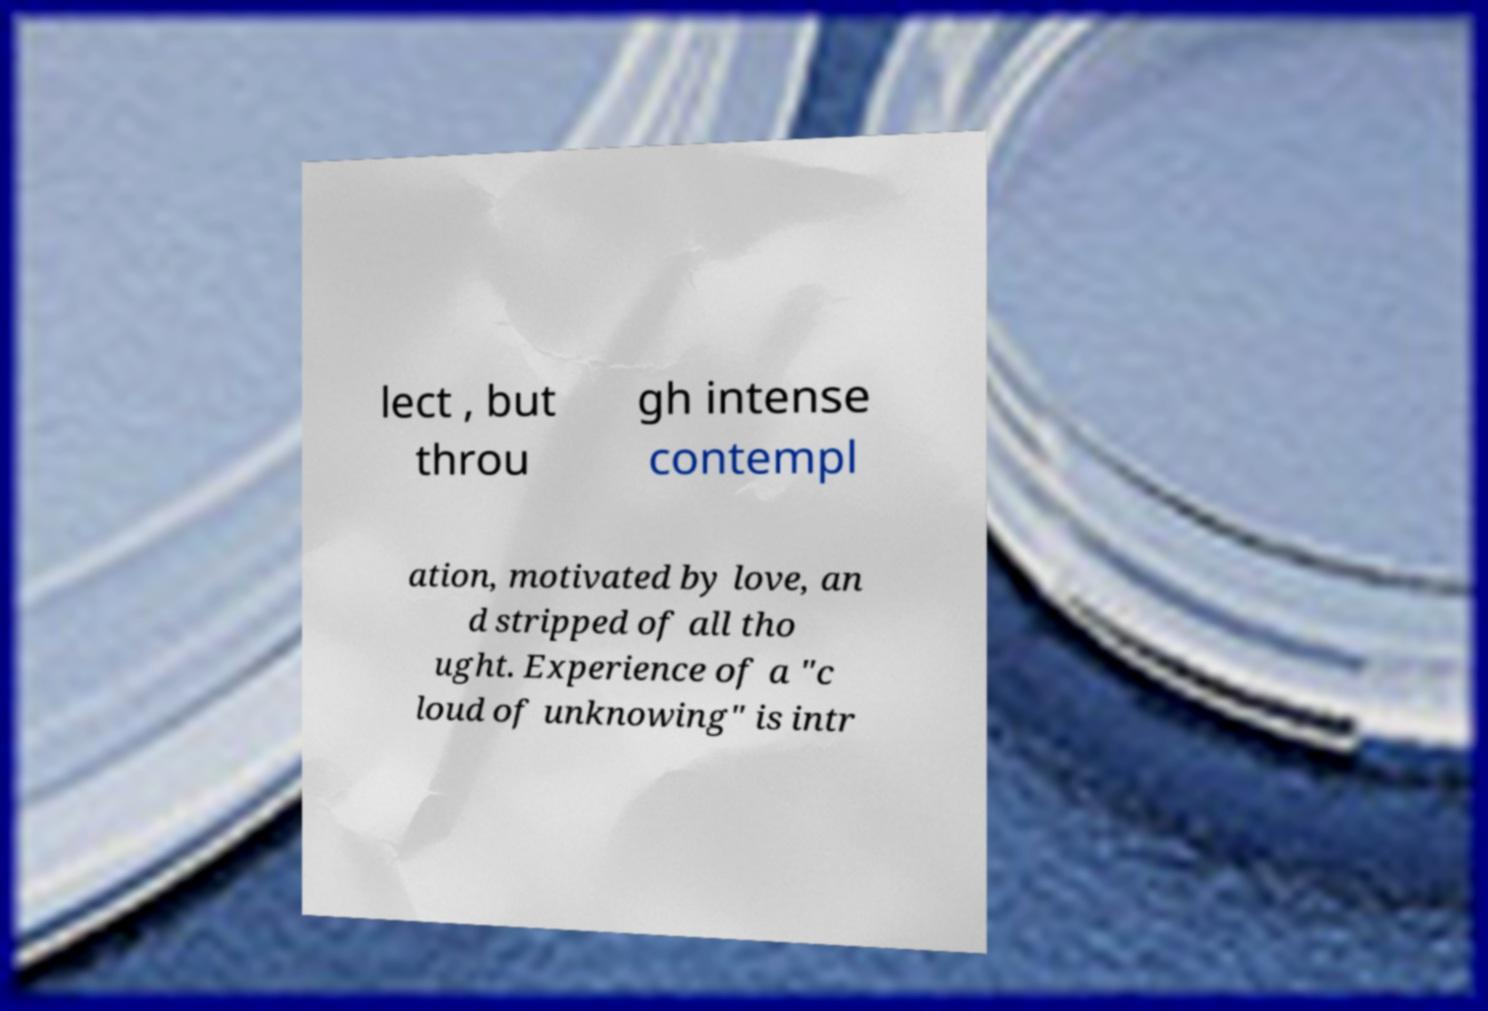There's text embedded in this image that I need extracted. Can you transcribe it verbatim? lect , but throu gh intense contempl ation, motivated by love, an d stripped of all tho ught. Experience of a "c loud of unknowing" is intr 